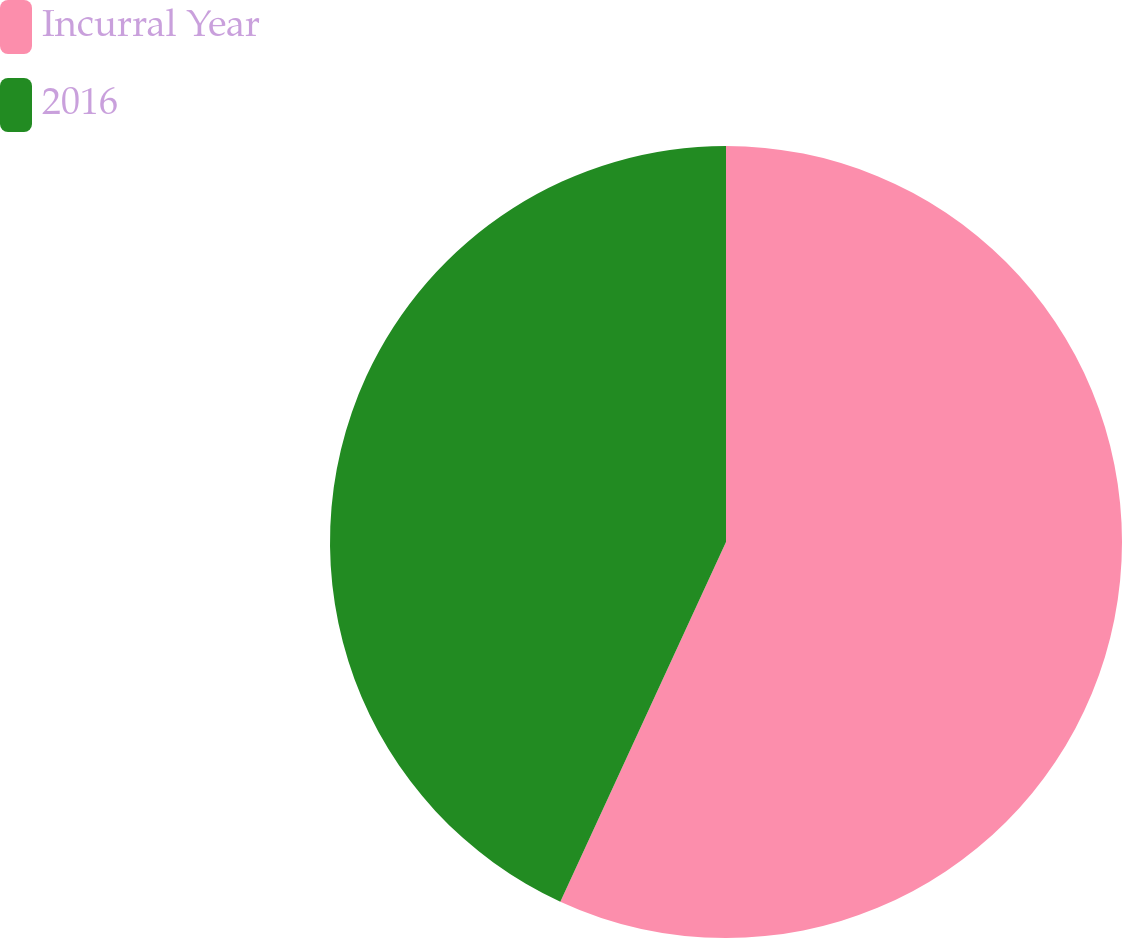Convert chart to OTSL. <chart><loc_0><loc_0><loc_500><loc_500><pie_chart><fcel>Incurral Year<fcel>2016<nl><fcel>56.87%<fcel>43.13%<nl></chart> 